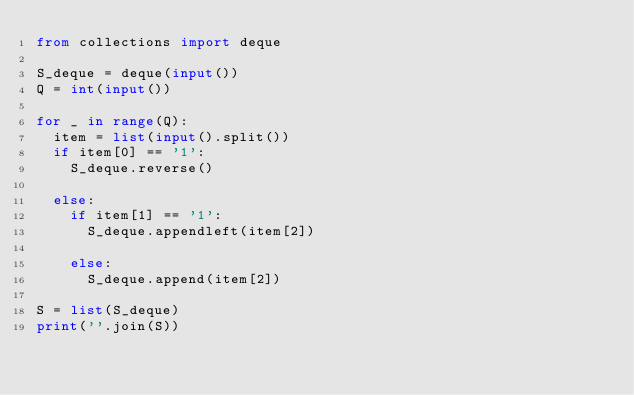<code> <loc_0><loc_0><loc_500><loc_500><_Python_>from collections import deque

S_deque = deque(input())
Q = int(input())

for _ in range(Q):
  item = list(input().split())
  if item[0] == '1':
    S_deque.reverse()

  else:
    if item[1] == '1':
      S_deque.appendleft(item[2])

    else:
      S_deque.append(item[2])

S = list(S_deque)
print(''.join(S))</code> 